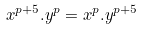Convert formula to latex. <formula><loc_0><loc_0><loc_500><loc_500>x ^ { p + 5 } . y ^ { p } = x ^ { p } . y ^ { p + 5 }</formula> 